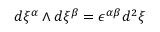<formula> <loc_0><loc_0><loc_500><loc_500>d \xi ^ { \alpha } \wedge d \xi ^ { \beta } = \epsilon ^ { \alpha \beta } d ^ { 2 } \xi</formula> 